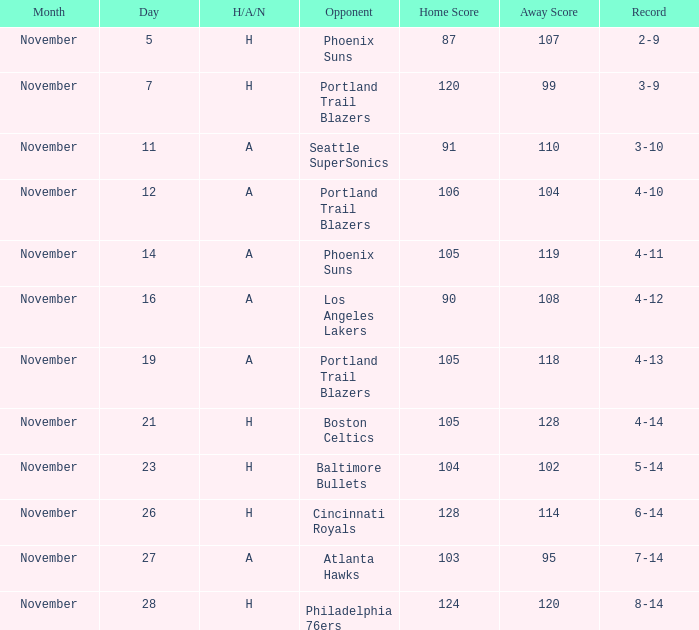On what Date was the Score 105-128? November 21. 